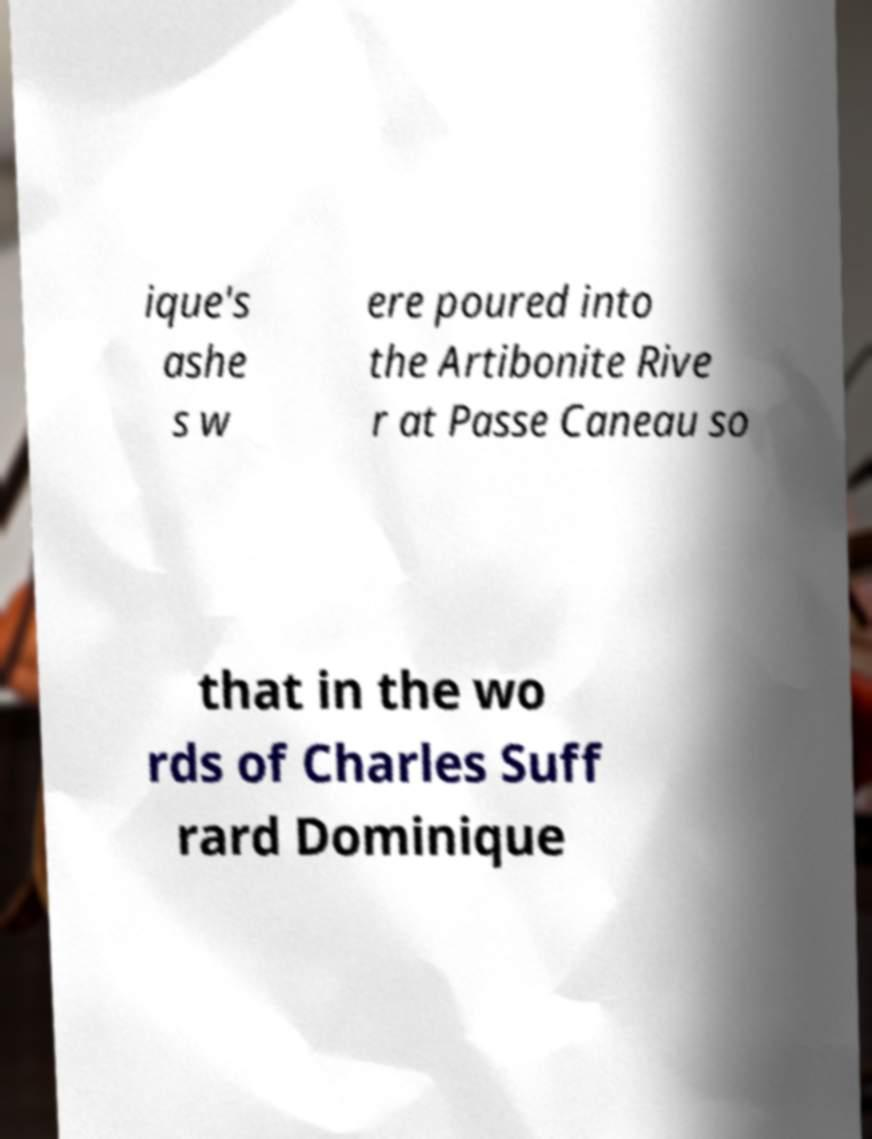For documentation purposes, I need the text within this image transcribed. Could you provide that? ique's ashe s w ere poured into the Artibonite Rive r at Passe Caneau so that in the wo rds of Charles Suff rard Dominique 